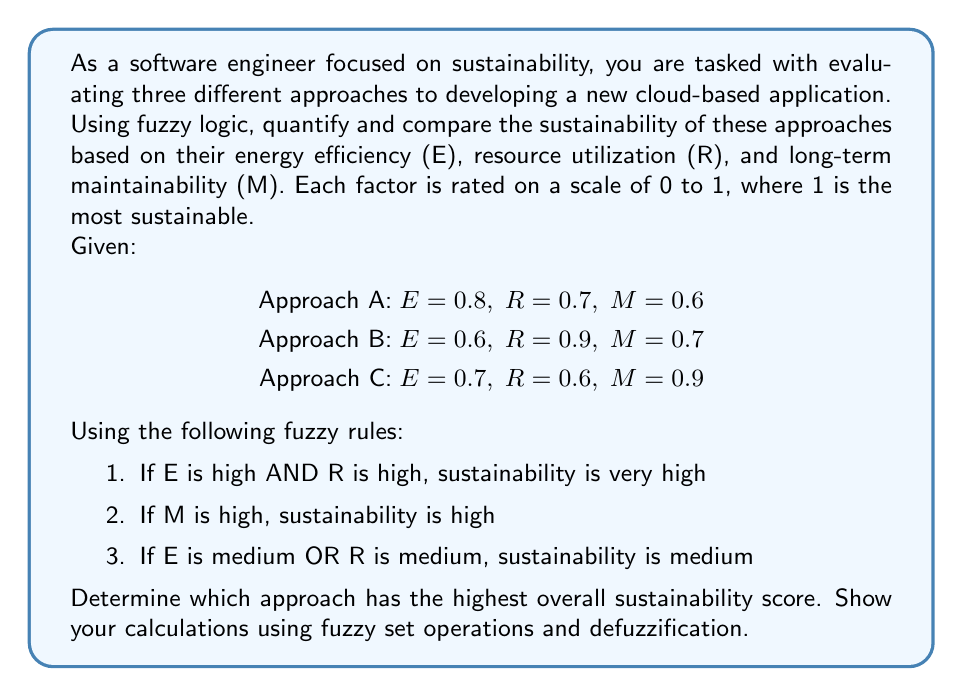Solve this math problem. To solve this problem, we'll use fuzzy logic operations to evaluate the sustainability of each approach. We'll follow these steps:

1. Define membership functions for linguistic variables (high, medium, low)
2. Apply fuzzy rules to determine degree of membership for each sustainability level
3. Combine the results using fuzzy set operations
4. Defuzzify the results to get a crisp sustainability score

Step 1: Define membership functions

Let's define simple triangular membership functions for high, medium, and low:

Low: $\mu_L(x) = \max(0, 1 - 2x)$
Medium: $\mu_M(x) = \max(0, \min(2x, 2 - 2x))$
High: $\mu_H(x) = \max(0, 2x - 1)$

Step 2: Apply fuzzy rules

For each approach, we'll apply the fuzzy rules:

Rule 1: $\min(\mu_H(E), \mu_H(R))$ for very high sustainability
Rule 2: $\mu_H(M)$ for high sustainability
Rule 3: $\max(\mu_M(E), \mu_M(R))$ for medium sustainability

Approach A:
$\mu_{VH} = \min(\mu_H(0.8), \mu_H(0.7)) = \min(0.6, 0.4) = 0.4$
$\mu_H = \mu_H(0.6) = 0.2$
$\mu_M = \max(\mu_M(0.8), \mu_M(0.7)) = \max(0.4, 0.6) = 0.6$

Approach B:
$\mu_{VH} = \min(\mu_H(0.6), \mu_H(0.9)) = \min(0.2, 0.8) = 0.2$
$\mu_H = \mu_H(0.7) = 0.4$
$\mu_M = \max(\mu_M(0.6), \mu_M(0.9)) = \max(0.8, 0.2) = 0.8$

Approach C:
$\mu_{VH} = \min(\mu_H(0.7), \mu_H(0.6)) = \min(0.4, 0.2) = 0.2$
$\mu_H = \mu_H(0.9) = 0.8$
$\mu_M = \max(\mu_M(0.7), \mu_M(0.6)) = \max(0.6, 0.8) = 0.8$

Step 3: Combine results

We'll use the maximum operator to combine the results:

Approach A: $\max(0.4, 0.2, 0.6) = 0.6$
Approach B: $\max(0.2, 0.4, 0.8) = 0.8$
Approach C: $\max(0.2, 0.8, 0.8) = 0.8$

Step 4: Defuzzification

To get a crisp sustainability score, we'll use the centroid method. We'll assume the following centroids for each sustainability level:

Very High: 0.9
High: 0.7
Medium: 0.5

The defuzzified score for each approach is:

Approach A: $\frac{0.4 \cdot 0.9 + 0.2 \cdot 0.7 + 0.6 \cdot 0.5}{0.4 + 0.2 + 0.6} = 0.65$

Approach B: $\frac{0.2 \cdot 0.9 + 0.4 \cdot 0.7 + 0.8 \cdot 0.5}{0.2 + 0.4 + 0.8} = 0.60$

Approach C: $\frac{0.2 \cdot 0.9 + 0.8 \cdot 0.7 + 0.8 \cdot 0.5}{0.2 + 0.8 + 0.8} = 0.61$
Answer: Based on the fuzzy logic analysis and defuzzification, Approach A has the highest overall sustainability score of 0.65, followed by Approach C with 0.61, and Approach B with 0.60. Therefore, Approach A is determined to be the most sustainable option among the three approaches. 